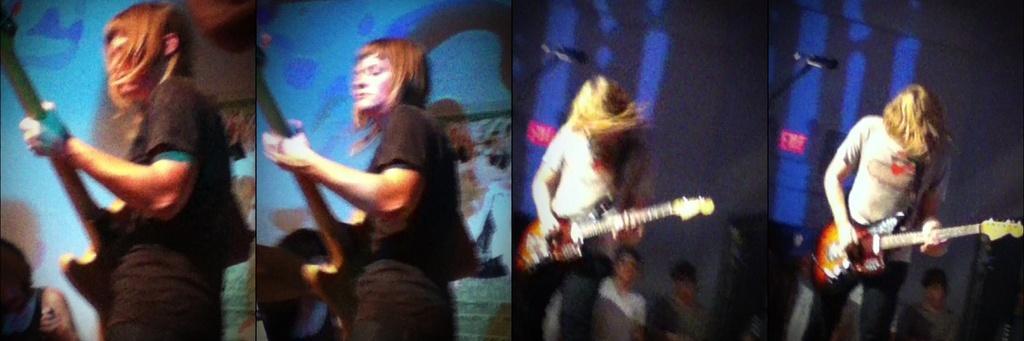Please provide a concise description of this image. This is collage edit with 4 images in it. There are 4 women in this pictures and all are playing guitar. 